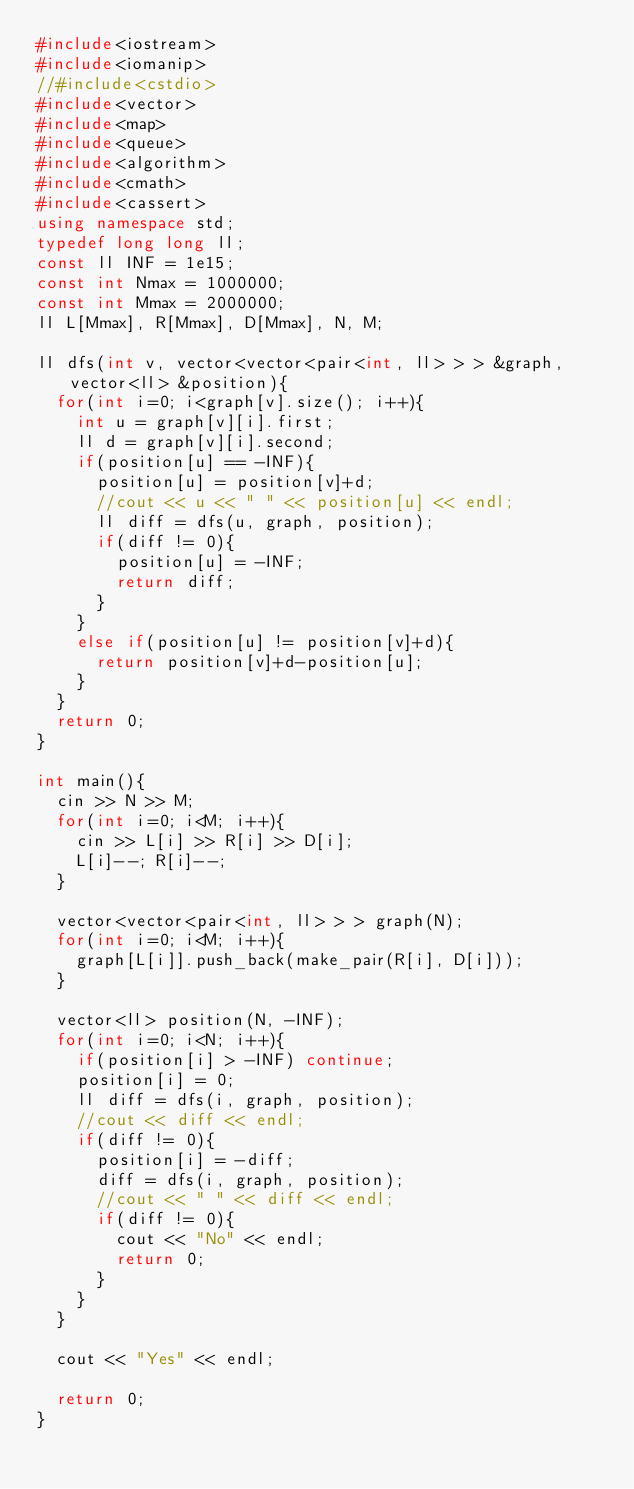<code> <loc_0><loc_0><loc_500><loc_500><_C++_>#include<iostream>
#include<iomanip>
//#include<cstdio>
#include<vector>
#include<map>
#include<queue>
#include<algorithm>
#include<cmath>
#include<cassert>
using namespace std;
typedef long long ll;
const ll INF = 1e15;
const int Nmax = 1000000;
const int Mmax = 2000000;
ll L[Mmax], R[Mmax], D[Mmax], N, M;

ll dfs(int v, vector<vector<pair<int, ll> > > &graph, vector<ll> &position){
	for(int i=0; i<graph[v].size(); i++){
		int u = graph[v][i].first;
		ll d = graph[v][i].second;
		if(position[u] == -INF){
			position[u] = position[v]+d;
			//cout << u << " " << position[u] << endl;
			ll diff = dfs(u, graph, position);
			if(diff != 0){
				position[u] = -INF;
				return diff;
			}
		}
		else if(position[u] != position[v]+d){
			return position[v]+d-position[u];
		}
	}
	return 0;
}

int main(){
	cin >> N >> M;
	for(int i=0; i<M; i++){
		cin >> L[i] >> R[i] >> D[i];
		L[i]--; R[i]--;
	}

	vector<vector<pair<int, ll> > > graph(N);
	for(int i=0; i<M; i++){
		graph[L[i]].push_back(make_pair(R[i], D[i]));
	}

	vector<ll> position(N, -INF);
	for(int i=0; i<N; i++){
		if(position[i] > -INF) continue;
		position[i] = 0;
		ll diff = dfs(i, graph, position);
		//cout << diff << endl;
		if(diff != 0){
			position[i] = -diff;
			diff = dfs(i, graph, position);
			//cout << " " << diff << endl;
			if(diff != 0){
				cout << "No" << endl;
				return 0;
			}
		}
	}

	cout << "Yes" << endl;

	return 0;
}
</code> 